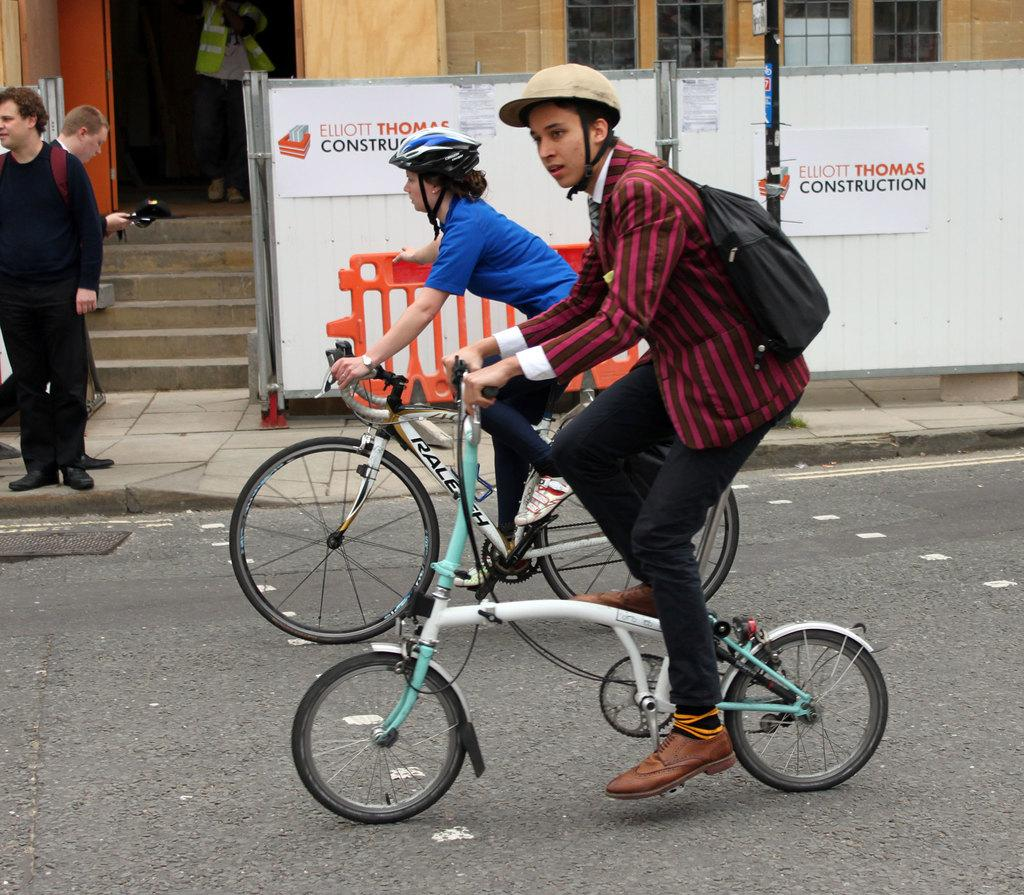What are the two persons doing in the image? The two persons are riding a bicycle on the road. Can you describe the person on the top left side of the image? There is a person standing on the top left side of the image. What can be seen in the background of the image? In the background, there are two persons on the top left side. What type of beef is being rubbed on the beam in the image? There is no beef or beam present in the image. 